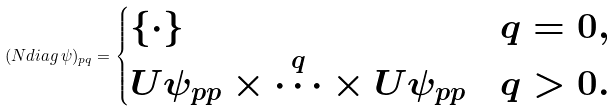Convert formula to latex. <formula><loc_0><loc_0><loc_500><loc_500>( N d i a g \, \psi ) _ { p q } = \begin{cases} \{ \cdot \} & q = 0 , \\ U \psi _ { p p } \times \overset { q } { \cdots } \times U \psi _ { p p } & q > 0 . \end{cases}</formula> 